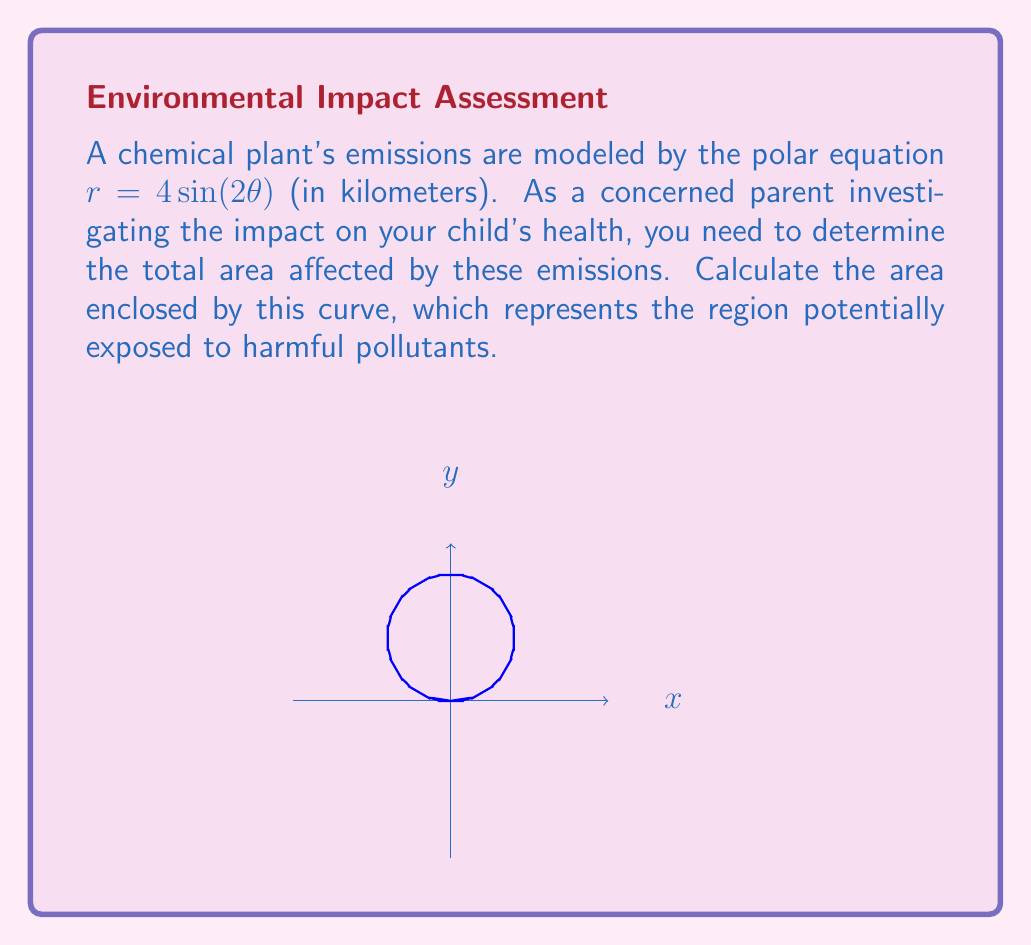Solve this math problem. To find the area enclosed by the polar curve $r = 4 \sin(2\theta)$, we'll use the formula for area in polar coordinates:

$$A = \frac{1}{2} \int_{0}^{2\pi} r^2 d\theta$$

Step 1: Substitute the given equation into the area formula.
$$A = \frac{1}{2} \int_{0}^{2\pi} (4 \sin(2\theta))^2 d\theta$$

Step 2: Simplify the integrand.
$$A = \frac{1}{2} \int_{0}^{2\pi} 16 \sin^2(2\theta) d\theta$$

Step 3: Use the trigonometric identity $\sin^2(x) = \frac{1 - \cos(2x)}{2}$.
$$A = \frac{1}{2} \int_{0}^{2\pi} 16 \cdot \frac{1 - \cos(4\theta)}{2} d\theta$$
$$A = 4 \int_{0}^{2\pi} (1 - \cos(4\theta)) d\theta$$

Step 4: Integrate.
$$A = 4 \left[\theta - \frac{1}{4}\sin(4\theta)\right]_{0}^{2\pi}$$

Step 5: Evaluate the integral at the limits.
$$A = 4 \left[(2\pi - 0) - (\frac{1}{4}\sin(8\pi) - \frac{1}{4}\sin(0))\right]$$
$$A = 4 \cdot 2\pi = 8\pi$$

Therefore, the area affected by the industrial emissions is $8\pi$ square kilometers.
Answer: $8\pi$ km² 